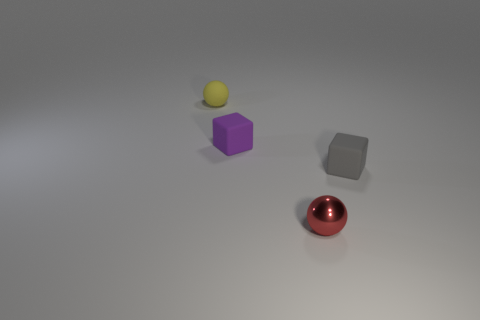Add 4 small blue rubber spheres. How many objects exist? 8 Subtract 1 cubes. How many cubes are left? 1 Subtract all purple cubes. How many cubes are left? 1 Subtract 0 blue cubes. How many objects are left? 4 Subtract all gray balls. Subtract all yellow cylinders. How many balls are left? 2 Subtract all blue cylinders. How many yellow spheres are left? 1 Subtract all tiny blue rubber objects. Subtract all small purple objects. How many objects are left? 3 Add 1 small shiny things. How many small shiny things are left? 2 Add 4 tiny purple cubes. How many tiny purple cubes exist? 5 